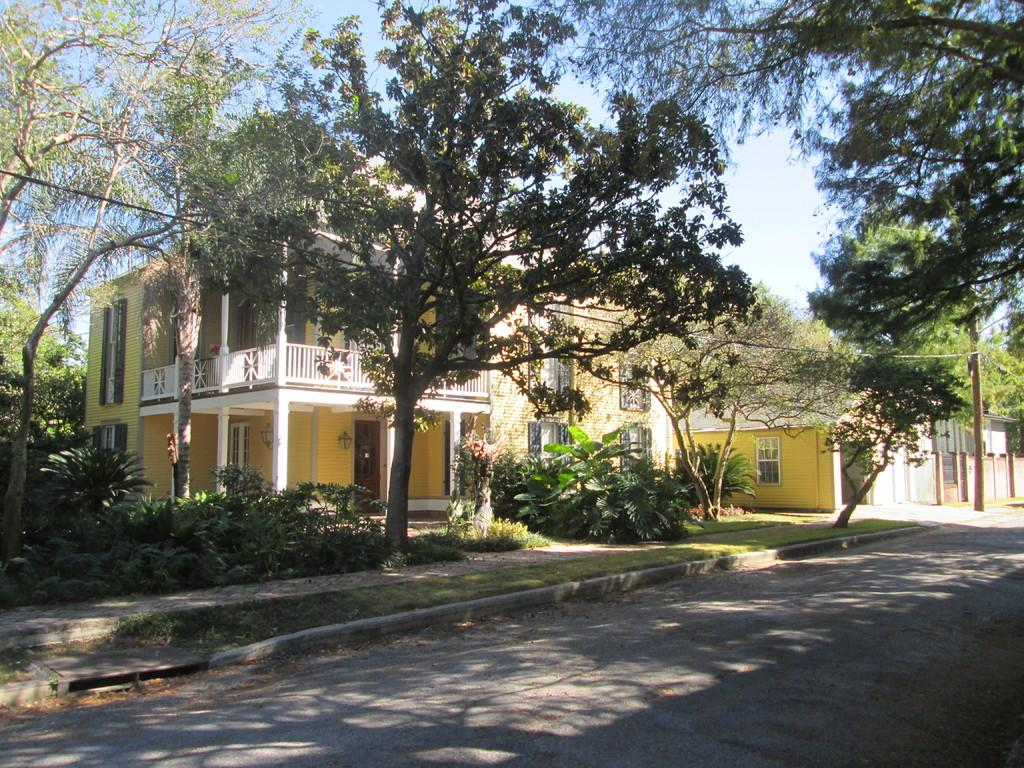What type of structures can be seen in the image? There are buildings in the image. What other natural elements are present in the image? There are plants and trees in the image. What can be seen in the background of the image? The sky is visible in the background of the image. What type of cake is being served by the father in the image? There is no cake or father present in the image. 